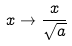Convert formula to latex. <formula><loc_0><loc_0><loc_500><loc_500>x \rightarrow \frac { x } { \sqrt { a } }</formula> 